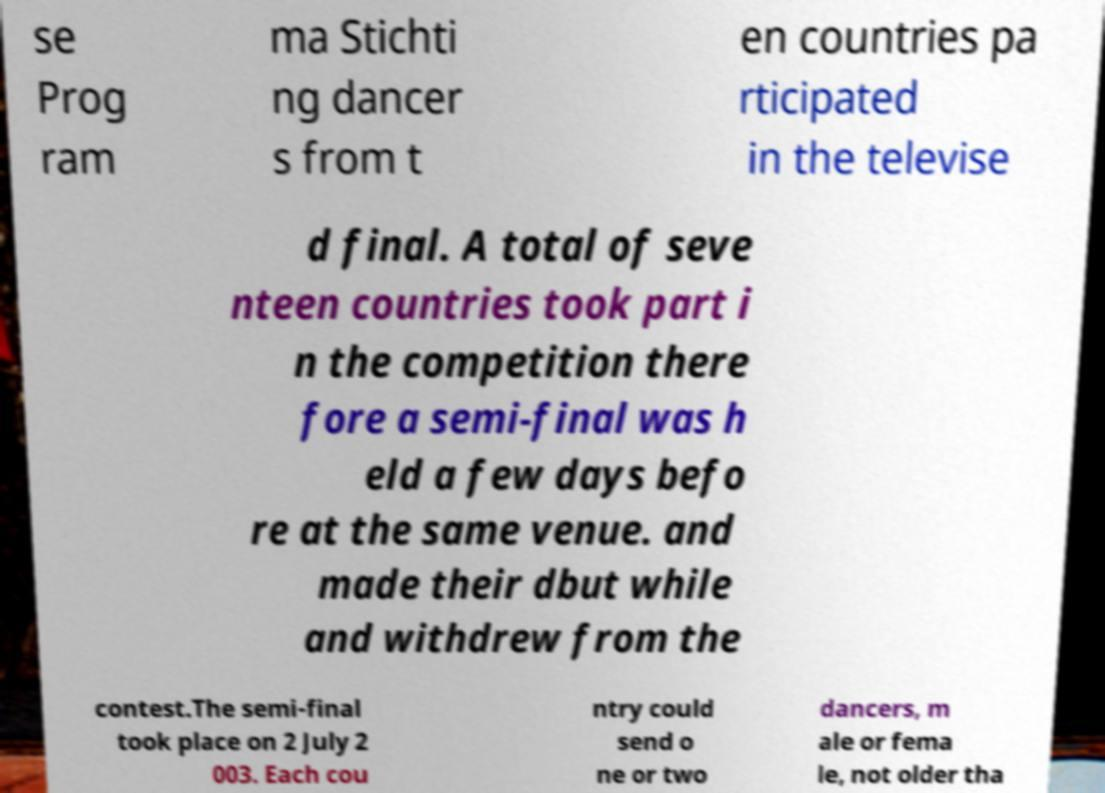Could you extract and type out the text from this image? se Prog ram ma Stichti ng dancer s from t en countries pa rticipated in the televise d final. A total of seve nteen countries took part i n the competition there fore a semi-final was h eld a few days befo re at the same venue. and made their dbut while and withdrew from the contest.The semi-final took place on 2 July 2 003. Each cou ntry could send o ne or two dancers, m ale or fema le, not older tha 